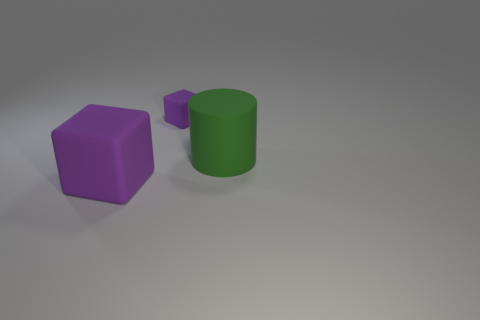Add 2 large green objects. How many objects exist? 5 Subtract all cylinders. How many objects are left? 2 Subtract 1 cylinders. How many cylinders are left? 0 Subtract all large brown rubber cubes. Subtract all big rubber cubes. How many objects are left? 2 Add 2 purple blocks. How many purple blocks are left? 4 Add 3 large gray metallic cubes. How many large gray metallic cubes exist? 3 Subtract 0 green balls. How many objects are left? 3 Subtract all cyan blocks. Subtract all purple spheres. How many blocks are left? 2 